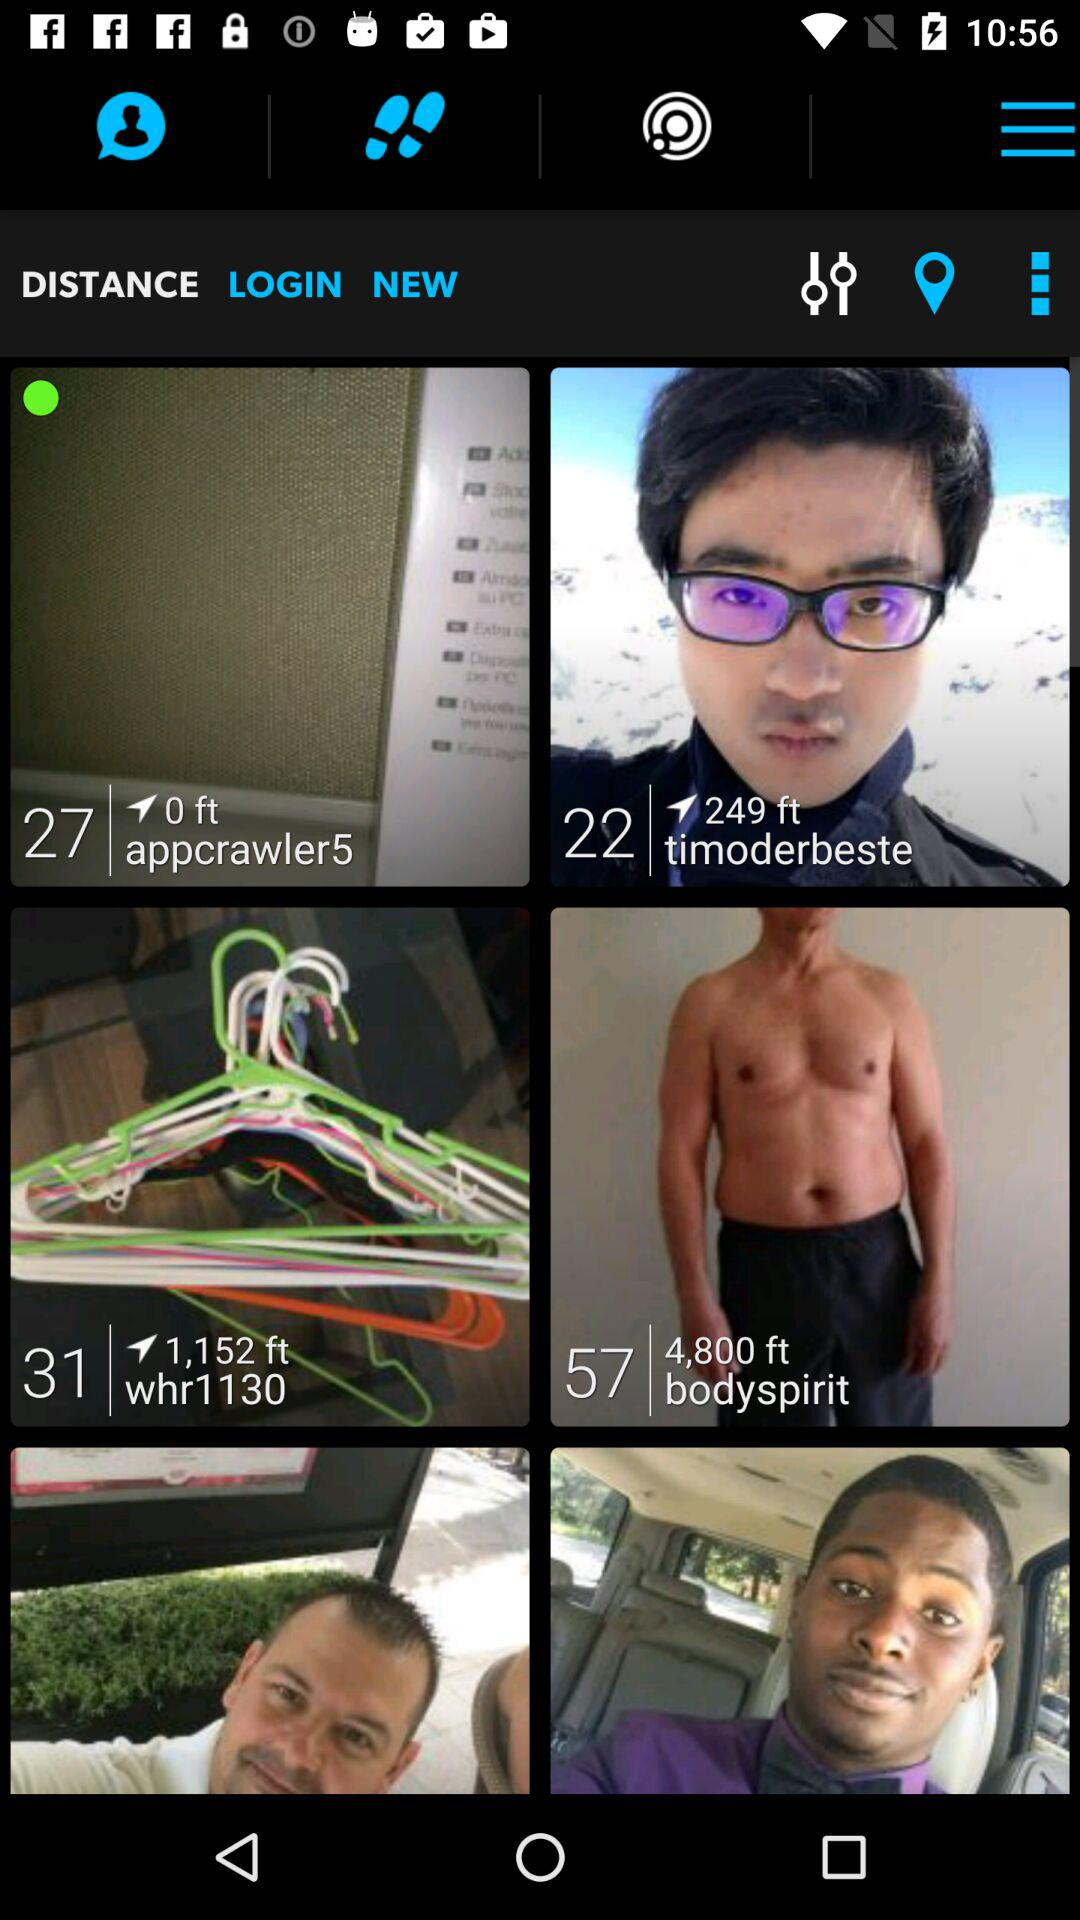What is the username of a person who is at the height of 249 ft? The username is "timoderbeste". 